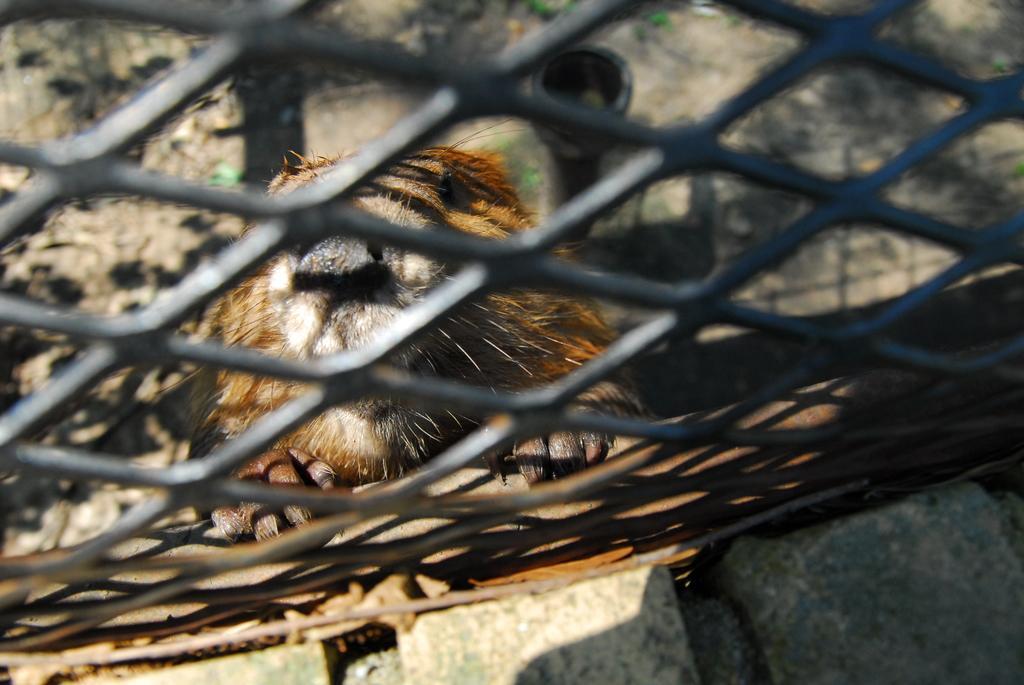Could you give a brief overview of what you see in this image? In this image we can see stones, grille, animal, and an object. Through the grille we can see ground. 